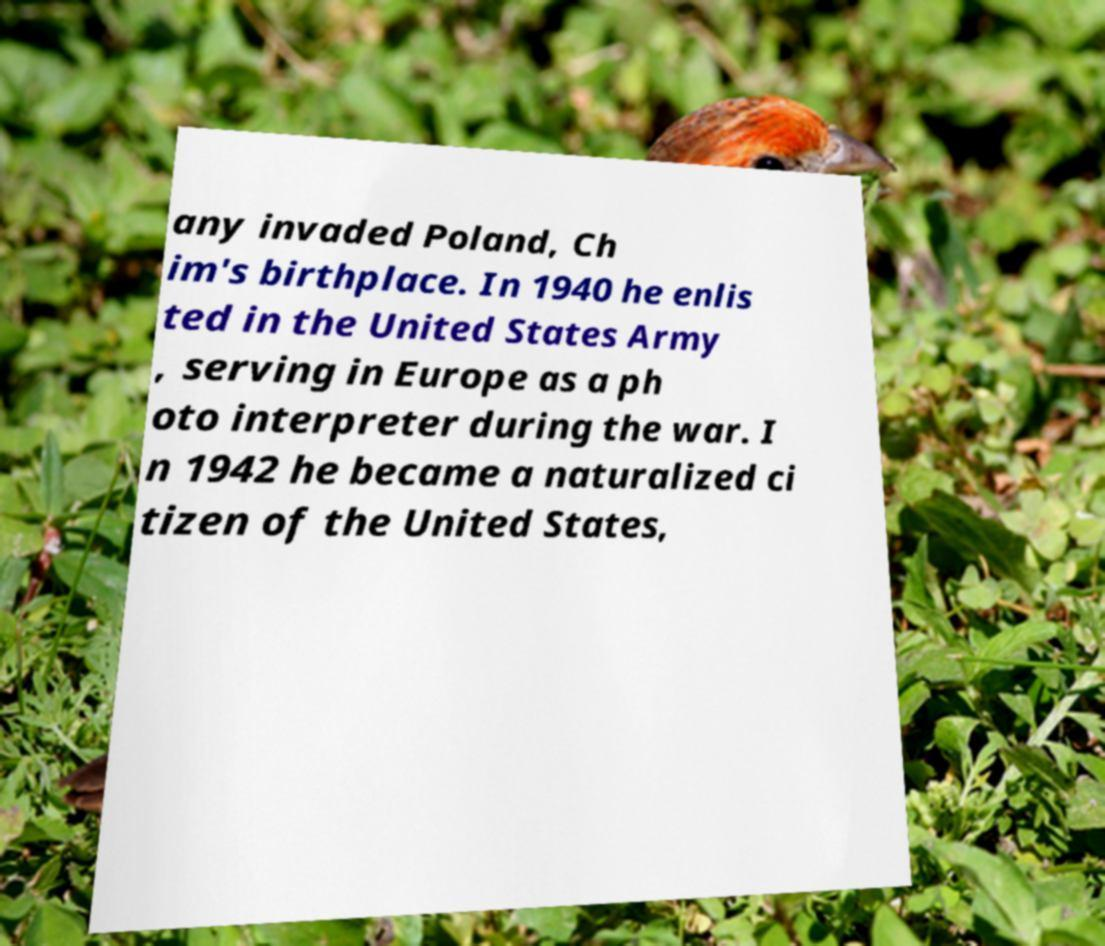Please read and relay the text visible in this image. What does it say? any invaded Poland, Ch im's birthplace. In 1940 he enlis ted in the United States Army , serving in Europe as a ph oto interpreter during the war. I n 1942 he became a naturalized ci tizen of the United States, 